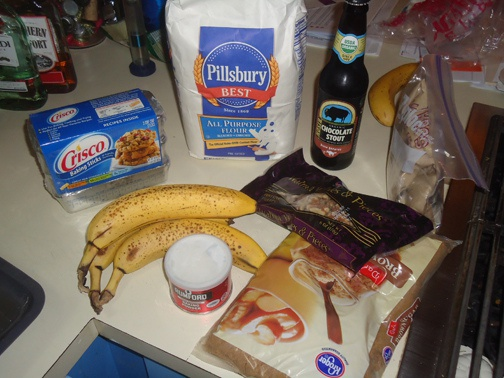Describe the objects in this image and their specific colors. I can see banana in black, tan, and olive tones, bottle in black, maroon, olive, and gray tones, bottle in black, gray, and darkgreen tones, bottle in black, gray, and maroon tones, and banana in black, maroon, olive, and gray tones in this image. 